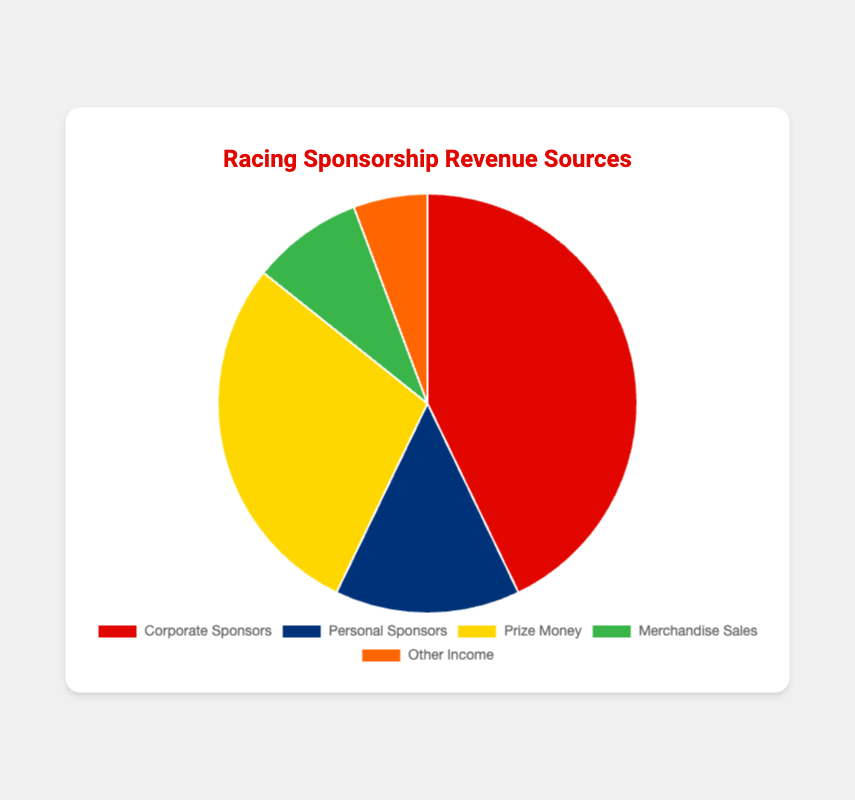What is the source of the highest revenue? By observing the pie chart, we can see that the segment for "Corporate Sponsors" is the largest. Therefore, "Corporate Sponsors" is the highest revenue source.
Answer: Corporate Sponsors Which category has the smallest revenue? By visually comparing the segments, "Other Income" appears to be the smallest.
Answer: Other Income What is the combined revenue from Personal Sponsors and Prize Money? We add the revenue from Personal Sponsors ($50,000) and Prize Money ($100,000). So, $50,000 + $100,000 = $150,000.
Answer: $150,000 How does the revenue from Merchandise Sales compare to that from Other Income? The pie chart shows that Merchandise Sales ($30,000) is larger than Other Income ($20,000).
Answer: Merchandise Sales is greater Which revenue source is depicted in green? By observing the colors of the segments, we see that the green segment represents "Merchandise Sales."
Answer: Merchandise Sales Calculate the percentage share of Corporate Sponsors relative to the total revenue. First, calculate the total revenue: $150,000 (Corporate Sponsors) + $50,000 (Personal Sponsors) + $100,000 (Prize Money) + $30,000 (Merchandise Sales) + $20,000 (Other Income) = $350,000. Then, calculate the percentage for Corporate Sponsors: ($150,000 / $350,000) * 100 ≈ 42.86%.
Answer: 42.86% Of Prize Money and Personal Sponsors, which contributed more to the revenue and by how much? Prize Money ($100,000) is larger than Personal Sponsors ($50,000). The difference is $100,000 - $50,000 = $50,000.
Answer: Prize Money by $50,000 What is the average revenue from all categories? First, find the total revenue: $350,000. Then, divide by the number of categories: $350,000 / 5 = $70,000.
Answer: $70,000 How much more is the revenue from Corporate Sponsors compared to Merchandise Sales? The revenue from Corporate Sponsors is $150,000, and from Merchandise Sales is $30,000. The difference is $150,000 - $30,000 = $120,000.
Answer: $120,000 Combine the revenue from Prize Money, Merchandise Sales, and Other Income. Add the revenues: $100,000 (Prize Money) + $30,000 (Merchandise Sales) + $20,000 (Other Income) = $150,000.
Answer: $150,000 